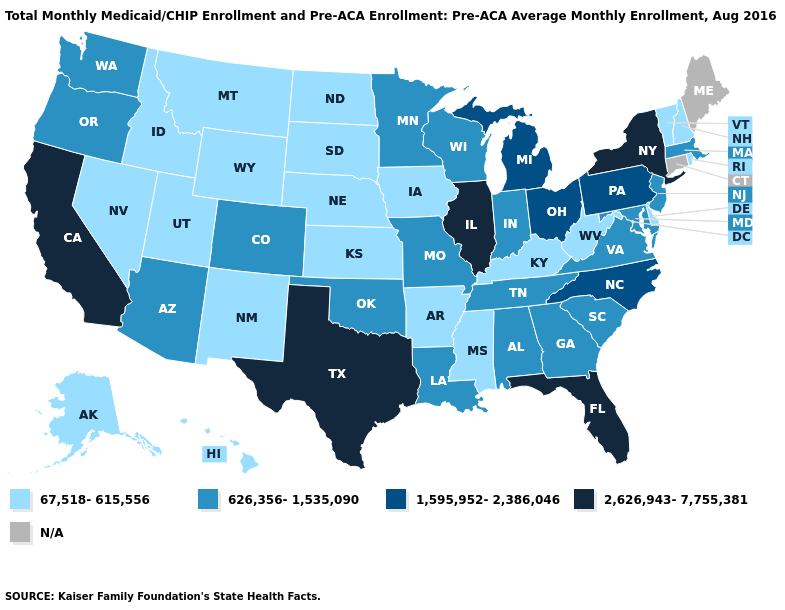Among the states that border Utah , does Wyoming have the lowest value?
Give a very brief answer. Yes. What is the value of Nebraska?
Short answer required. 67,518-615,556. What is the value of Connecticut?
Quick response, please. N/A. Which states have the lowest value in the USA?
Answer briefly. Alaska, Arkansas, Delaware, Hawaii, Idaho, Iowa, Kansas, Kentucky, Mississippi, Montana, Nebraska, Nevada, New Hampshire, New Mexico, North Dakota, Rhode Island, South Dakota, Utah, Vermont, West Virginia, Wyoming. What is the lowest value in states that border Idaho?
Keep it brief. 67,518-615,556. Does Indiana have the lowest value in the MidWest?
Keep it brief. No. Name the states that have a value in the range 626,356-1,535,090?
Write a very short answer. Alabama, Arizona, Colorado, Georgia, Indiana, Louisiana, Maryland, Massachusetts, Minnesota, Missouri, New Jersey, Oklahoma, Oregon, South Carolina, Tennessee, Virginia, Washington, Wisconsin. What is the value of South Carolina?
Quick response, please. 626,356-1,535,090. What is the value of Georgia?
Answer briefly. 626,356-1,535,090. Which states hav the highest value in the Northeast?
Concise answer only. New York. Name the states that have a value in the range 626,356-1,535,090?
Write a very short answer. Alabama, Arizona, Colorado, Georgia, Indiana, Louisiana, Maryland, Massachusetts, Minnesota, Missouri, New Jersey, Oklahoma, Oregon, South Carolina, Tennessee, Virginia, Washington, Wisconsin. Among the states that border Arizona , which have the lowest value?
Keep it brief. Nevada, New Mexico, Utah. What is the value of Tennessee?
Be succinct. 626,356-1,535,090. Is the legend a continuous bar?
Quick response, please. No. 